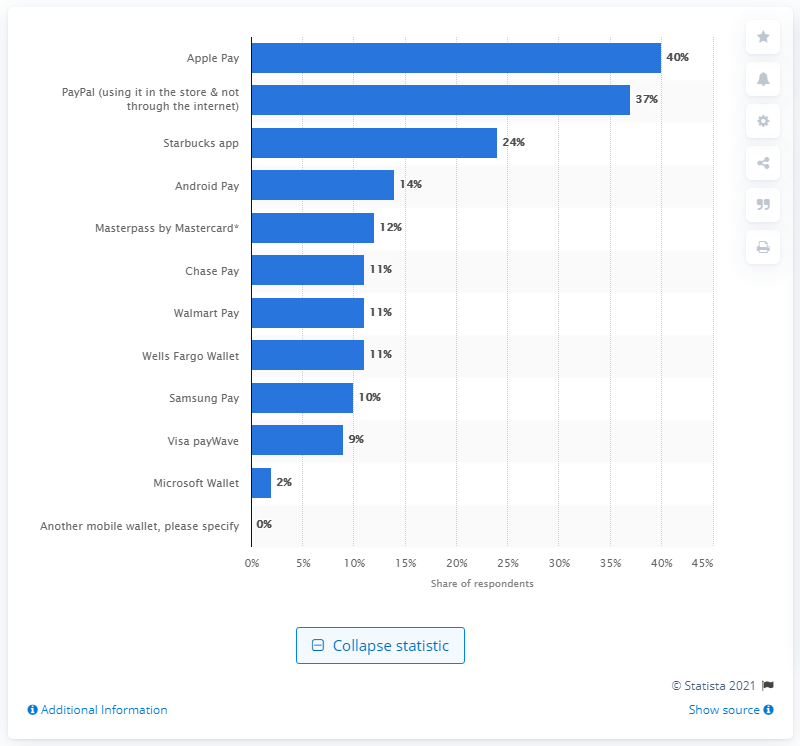Highlight a few significant elements in this photo. According to a survey, 14% of mobile wallet users preferred to use Android Pay to pay at in-store checkout. 